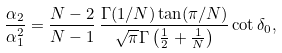Convert formula to latex. <formula><loc_0><loc_0><loc_500><loc_500>\frac { \alpha _ { 2 } } { \alpha _ { 1 } ^ { 2 } } = \frac { N - 2 } { N - 1 } \, \frac { \Gamma ( 1 / N ) \tan ( \pi / N ) } { \sqrt { \pi } \Gamma \left ( \frac { 1 } { 2 } + \frac { 1 } { N } \right ) } \cot \delta _ { 0 } ,</formula> 